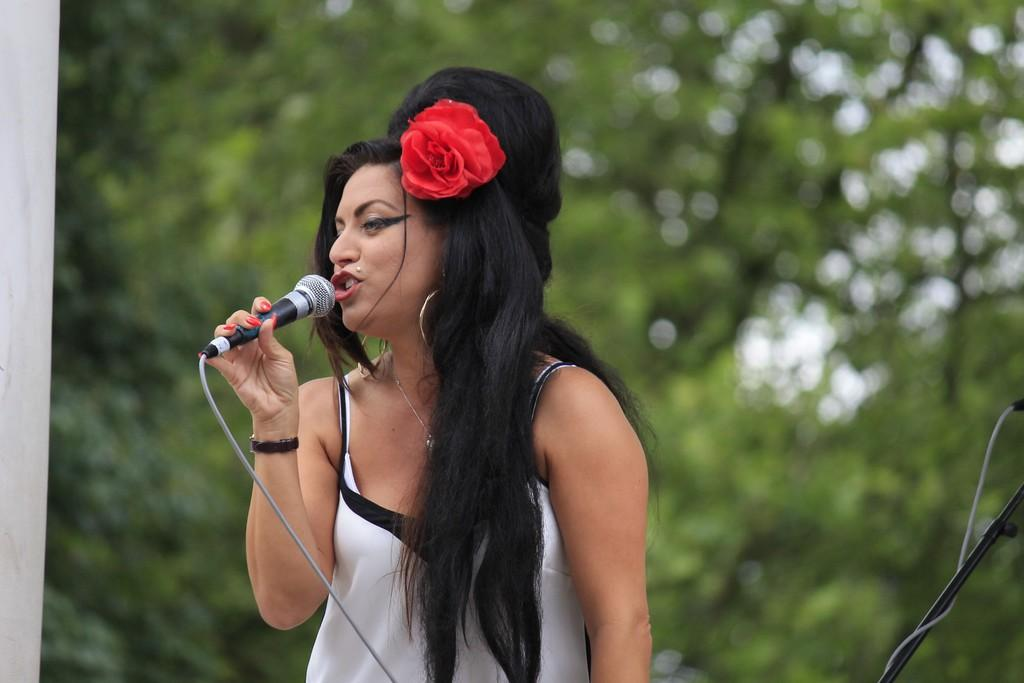Who is the main subject in the image? There is a woman in the image. Where is the woman located in the image? The woman is in the center of the image. What is the woman doing in the image? The woman is singing. What object is the woman holding in the image? The woman is holding a microphone. What type of doctor is standing next to the woman in the image? There is no doctor present in the image; it only features a woman singing and holding a microphone. 